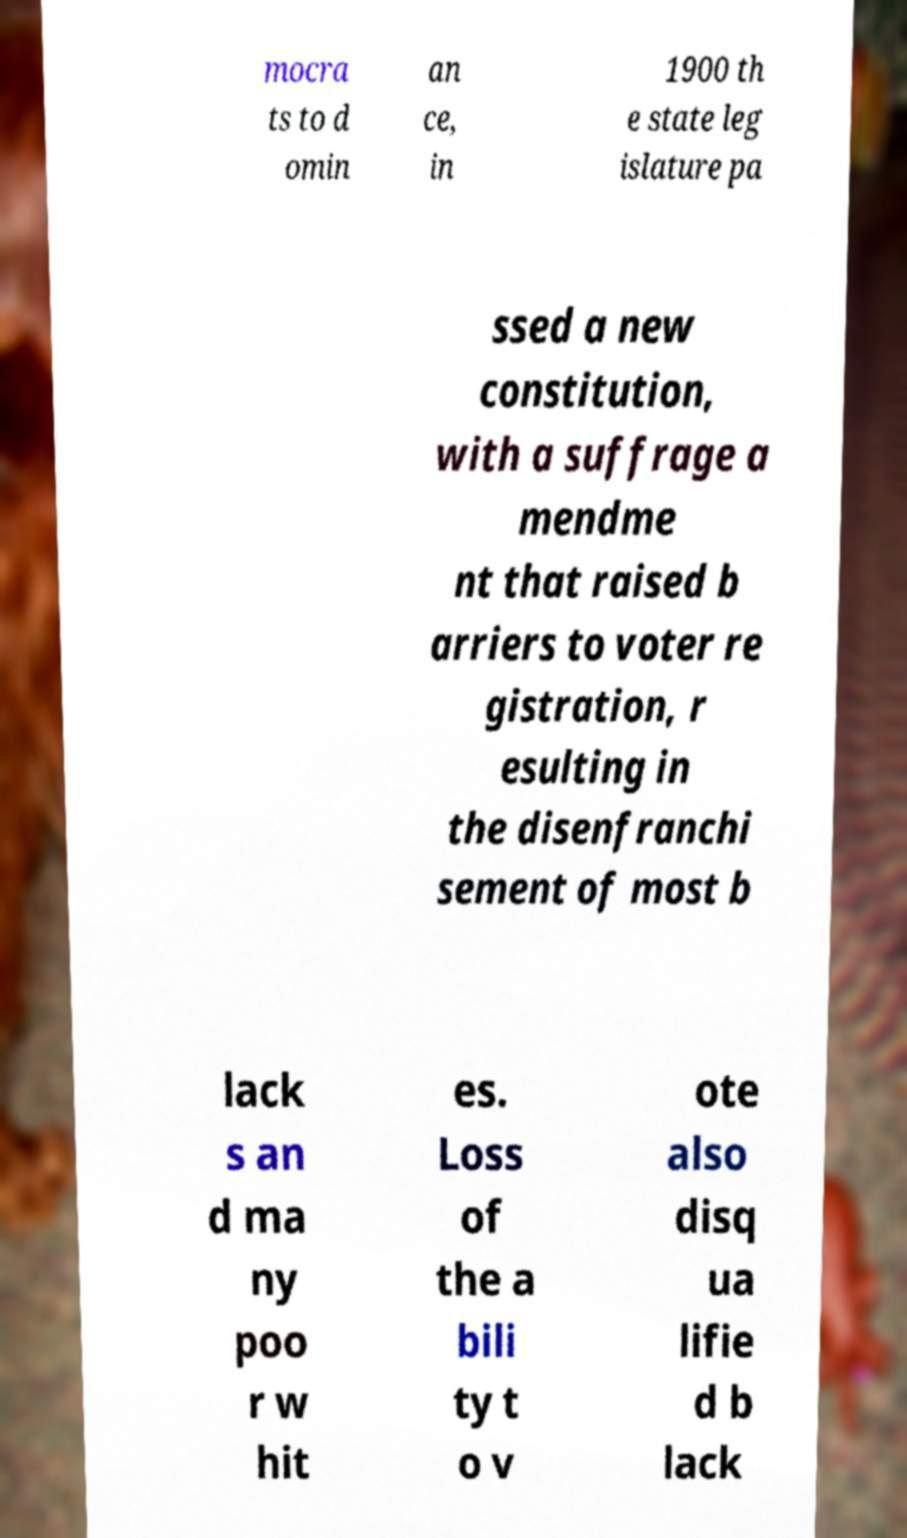There's text embedded in this image that I need extracted. Can you transcribe it verbatim? mocra ts to d omin an ce, in 1900 th e state leg islature pa ssed a new constitution, with a suffrage a mendme nt that raised b arriers to voter re gistration, r esulting in the disenfranchi sement of most b lack s an d ma ny poo r w hit es. Loss of the a bili ty t o v ote also disq ua lifie d b lack 